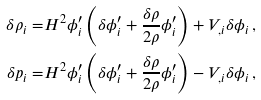<formula> <loc_0><loc_0><loc_500><loc_500>\delta \rho _ { i } = & H ^ { 2 } \phi _ { i } ^ { \prime } \left ( \delta \phi _ { i } ^ { \prime } + \frac { \delta \rho } { 2 \rho } \phi _ { i } ^ { \prime } \right ) + V _ { , i } \delta \phi _ { i } \, , \\ \delta p _ { i } = & H ^ { 2 } \phi _ { i } ^ { \prime } \left ( \delta \phi _ { i } ^ { \prime } + \frac { \delta \rho } { 2 \rho } \phi _ { i } ^ { \prime } \right ) - V _ { , i } \delta \phi _ { i } \, ,</formula> 